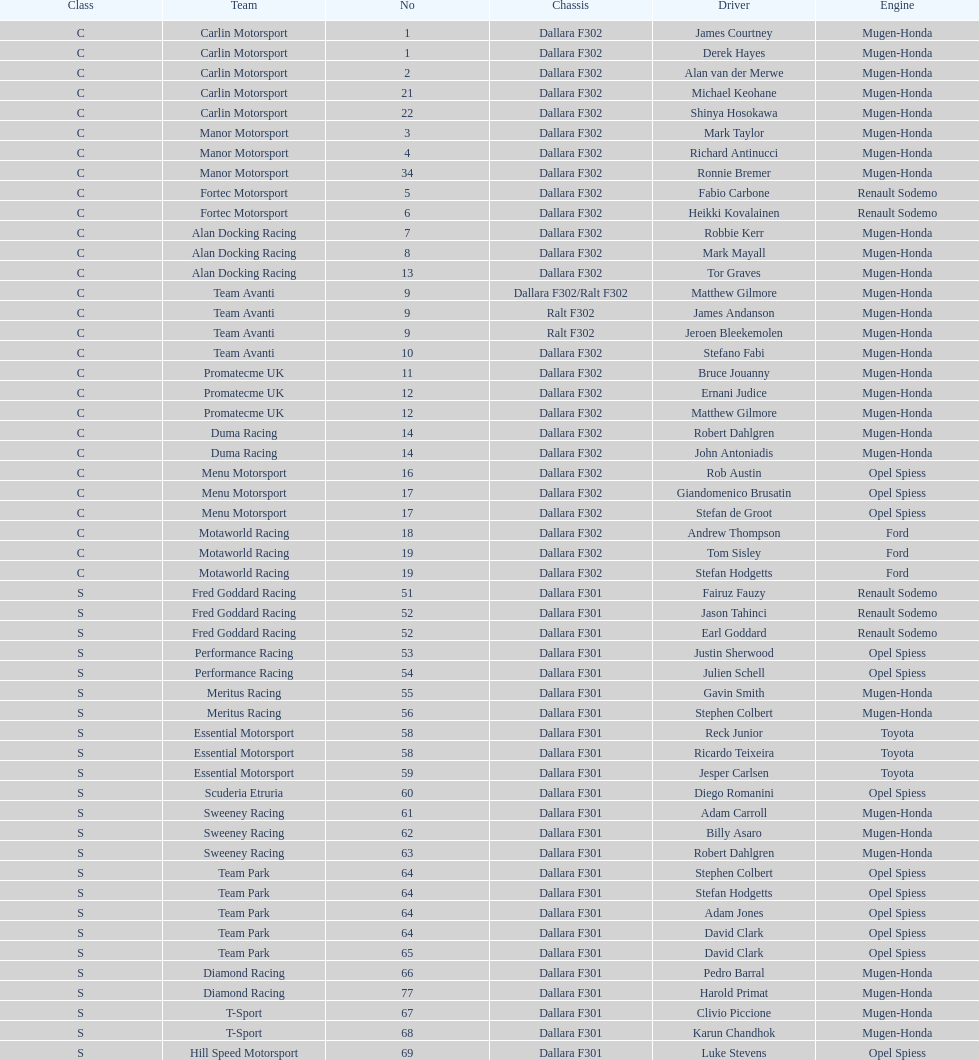Parse the full table. {'header': ['Class', 'Team', 'No', 'Chassis', 'Driver', 'Engine'], 'rows': [['C', 'Carlin Motorsport', '1', 'Dallara F302', 'James Courtney', 'Mugen-Honda'], ['C', 'Carlin Motorsport', '1', 'Dallara F302', 'Derek Hayes', 'Mugen-Honda'], ['C', 'Carlin Motorsport', '2', 'Dallara F302', 'Alan van der Merwe', 'Mugen-Honda'], ['C', 'Carlin Motorsport', '21', 'Dallara F302', 'Michael Keohane', 'Mugen-Honda'], ['C', 'Carlin Motorsport', '22', 'Dallara F302', 'Shinya Hosokawa', 'Mugen-Honda'], ['C', 'Manor Motorsport', '3', 'Dallara F302', 'Mark Taylor', 'Mugen-Honda'], ['C', 'Manor Motorsport', '4', 'Dallara F302', 'Richard Antinucci', 'Mugen-Honda'], ['C', 'Manor Motorsport', '34', 'Dallara F302', 'Ronnie Bremer', 'Mugen-Honda'], ['C', 'Fortec Motorsport', '5', 'Dallara F302', 'Fabio Carbone', 'Renault Sodemo'], ['C', 'Fortec Motorsport', '6', 'Dallara F302', 'Heikki Kovalainen', 'Renault Sodemo'], ['C', 'Alan Docking Racing', '7', 'Dallara F302', 'Robbie Kerr', 'Mugen-Honda'], ['C', 'Alan Docking Racing', '8', 'Dallara F302', 'Mark Mayall', 'Mugen-Honda'], ['C', 'Alan Docking Racing', '13', 'Dallara F302', 'Tor Graves', 'Mugen-Honda'], ['C', 'Team Avanti', '9', 'Dallara F302/Ralt F302', 'Matthew Gilmore', 'Mugen-Honda'], ['C', 'Team Avanti', '9', 'Ralt F302', 'James Andanson', 'Mugen-Honda'], ['C', 'Team Avanti', '9', 'Ralt F302', 'Jeroen Bleekemolen', 'Mugen-Honda'], ['C', 'Team Avanti', '10', 'Dallara F302', 'Stefano Fabi', 'Mugen-Honda'], ['C', 'Promatecme UK', '11', 'Dallara F302', 'Bruce Jouanny', 'Mugen-Honda'], ['C', 'Promatecme UK', '12', 'Dallara F302', 'Ernani Judice', 'Mugen-Honda'], ['C', 'Promatecme UK', '12', 'Dallara F302', 'Matthew Gilmore', 'Mugen-Honda'], ['C', 'Duma Racing', '14', 'Dallara F302', 'Robert Dahlgren', 'Mugen-Honda'], ['C', 'Duma Racing', '14', 'Dallara F302', 'John Antoniadis', 'Mugen-Honda'], ['C', 'Menu Motorsport', '16', 'Dallara F302', 'Rob Austin', 'Opel Spiess'], ['C', 'Menu Motorsport', '17', 'Dallara F302', 'Giandomenico Brusatin', 'Opel Spiess'], ['C', 'Menu Motorsport', '17', 'Dallara F302', 'Stefan de Groot', 'Opel Spiess'], ['C', 'Motaworld Racing', '18', 'Dallara F302', 'Andrew Thompson', 'Ford'], ['C', 'Motaworld Racing', '19', 'Dallara F302', 'Tom Sisley', 'Ford'], ['C', 'Motaworld Racing', '19', 'Dallara F302', 'Stefan Hodgetts', 'Ford'], ['S', 'Fred Goddard Racing', '51', 'Dallara F301', 'Fairuz Fauzy', 'Renault Sodemo'], ['S', 'Fred Goddard Racing', '52', 'Dallara F301', 'Jason Tahinci', 'Renault Sodemo'], ['S', 'Fred Goddard Racing', '52', 'Dallara F301', 'Earl Goddard', 'Renault Sodemo'], ['S', 'Performance Racing', '53', 'Dallara F301', 'Justin Sherwood', 'Opel Spiess'], ['S', 'Performance Racing', '54', 'Dallara F301', 'Julien Schell', 'Opel Spiess'], ['S', 'Meritus Racing', '55', 'Dallara F301', 'Gavin Smith', 'Mugen-Honda'], ['S', 'Meritus Racing', '56', 'Dallara F301', 'Stephen Colbert', 'Mugen-Honda'], ['S', 'Essential Motorsport', '58', 'Dallara F301', 'Reck Junior', 'Toyota'], ['S', 'Essential Motorsport', '58', 'Dallara F301', 'Ricardo Teixeira', 'Toyota'], ['S', 'Essential Motorsport', '59', 'Dallara F301', 'Jesper Carlsen', 'Toyota'], ['S', 'Scuderia Etruria', '60', 'Dallara F301', 'Diego Romanini', 'Opel Spiess'], ['S', 'Sweeney Racing', '61', 'Dallara F301', 'Adam Carroll', 'Mugen-Honda'], ['S', 'Sweeney Racing', '62', 'Dallara F301', 'Billy Asaro', 'Mugen-Honda'], ['S', 'Sweeney Racing', '63', 'Dallara F301', 'Robert Dahlgren', 'Mugen-Honda'], ['S', 'Team Park', '64', 'Dallara F301', 'Stephen Colbert', 'Opel Spiess'], ['S', 'Team Park', '64', 'Dallara F301', 'Stefan Hodgetts', 'Opel Spiess'], ['S', 'Team Park', '64', 'Dallara F301', 'Adam Jones', 'Opel Spiess'], ['S', 'Team Park', '64', 'Dallara F301', 'David Clark', 'Opel Spiess'], ['S', 'Team Park', '65', 'Dallara F301', 'David Clark', 'Opel Spiess'], ['S', 'Diamond Racing', '66', 'Dallara F301', 'Pedro Barral', 'Mugen-Honda'], ['S', 'Diamond Racing', '77', 'Dallara F301', 'Harold Primat', 'Mugen-Honda'], ['S', 'T-Sport', '67', 'Dallara F301', 'Clivio Piccione', 'Mugen-Honda'], ['S', 'T-Sport', '68', 'Dallara F301', 'Karun Chandhok', 'Mugen-Honda'], ['S', 'Hill Speed Motorsport', '69', 'Dallara F301', 'Luke Stevens', 'Opel Spiess']]} What is the total number of class c (championship) teams? 21. 